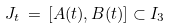<formula> <loc_0><loc_0><loc_500><loc_500>J _ { t } \, = \, [ A ( t ) , B ( t ) ] \subset I _ { 3 }</formula> 